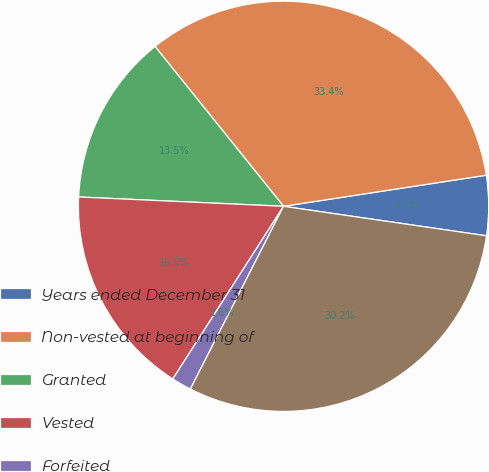Convert chart to OTSL. <chart><loc_0><loc_0><loc_500><loc_500><pie_chart><fcel>Years ended December 31<fcel>Non-vested at beginning of<fcel>Granted<fcel>Vested<fcel>Forfeited<fcel>Non-vested at end of year<nl><fcel>4.72%<fcel>33.36%<fcel>13.5%<fcel>16.65%<fcel>1.57%<fcel>30.21%<nl></chart> 